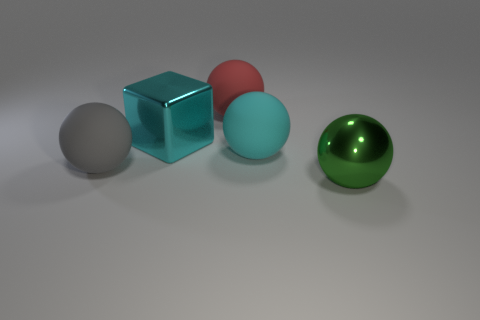How many large shiny objects are both on the right side of the big red object and behind the large cyan ball? 0 